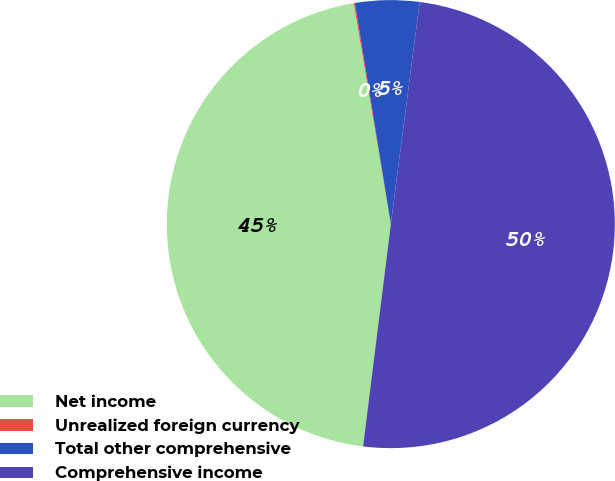Convert chart to OTSL. <chart><loc_0><loc_0><loc_500><loc_500><pie_chart><fcel>Net income<fcel>Unrealized foreign currency<fcel>Total other comprehensive<fcel>Comprehensive income<nl><fcel>45.38%<fcel>0.08%<fcel>4.62%<fcel>49.92%<nl></chart> 